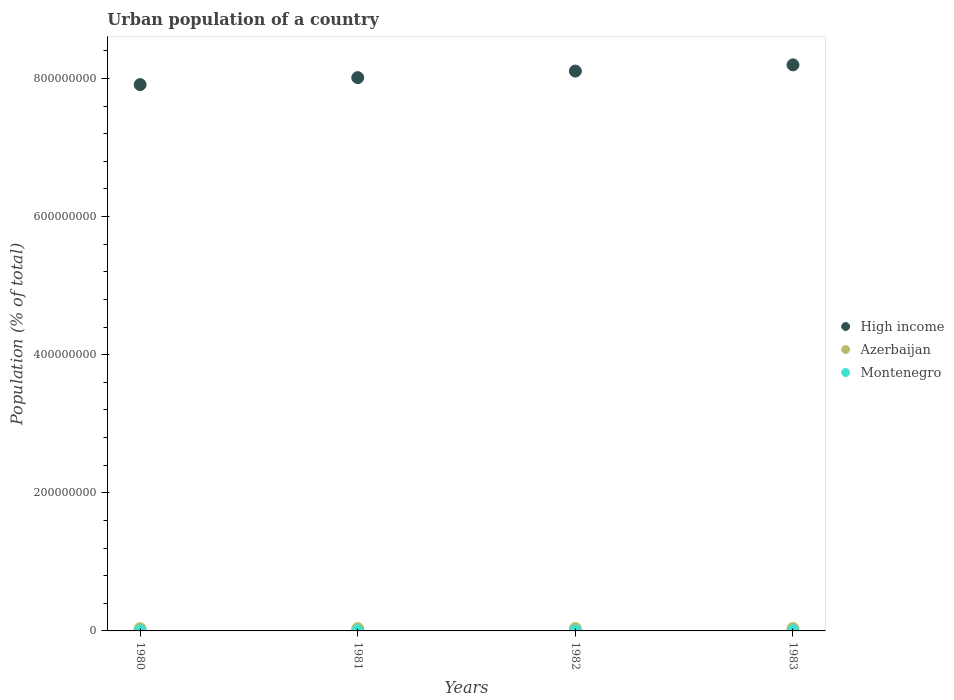Is the number of dotlines equal to the number of legend labels?
Make the answer very short. Yes. What is the urban population in Azerbaijan in 1982?
Offer a terse response. 3.37e+06. Across all years, what is the maximum urban population in High income?
Provide a short and direct response. 8.20e+08. Across all years, what is the minimum urban population in High income?
Make the answer very short. 7.91e+08. In which year was the urban population in Montenegro maximum?
Provide a short and direct response. 1983. What is the total urban population in Montenegro in the graph?
Ensure brevity in your answer.  8.89e+05. What is the difference between the urban population in High income in 1981 and that in 1983?
Give a very brief answer. -1.85e+07. What is the difference between the urban population in High income in 1983 and the urban population in Azerbaijan in 1980?
Offer a very short reply. 8.16e+08. What is the average urban population in Montenegro per year?
Your answer should be very brief. 2.22e+05. In the year 1983, what is the difference between the urban population in Montenegro and urban population in Azerbaijan?
Provide a short and direct response. -3.20e+06. In how many years, is the urban population in High income greater than 40000000 %?
Make the answer very short. 4. What is the ratio of the urban population in Montenegro in 1981 to that in 1983?
Offer a very short reply. 0.94. What is the difference between the highest and the second highest urban population in Azerbaijan?
Provide a succinct answer. 6.22e+04. What is the difference between the highest and the lowest urban population in High income?
Ensure brevity in your answer.  2.86e+07. Does the urban population in Montenegro monotonically increase over the years?
Give a very brief answer. Yes. Is the urban population in Azerbaijan strictly greater than the urban population in High income over the years?
Keep it short and to the point. No. Are the values on the major ticks of Y-axis written in scientific E-notation?
Keep it short and to the point. No. Where does the legend appear in the graph?
Offer a very short reply. Center right. How many legend labels are there?
Provide a short and direct response. 3. What is the title of the graph?
Provide a short and direct response. Urban population of a country. Does "Sub-Saharan Africa (developing only)" appear as one of the legend labels in the graph?
Keep it short and to the point. No. What is the label or title of the Y-axis?
Offer a terse response. Population (% of total). What is the Population (% of total) in High income in 1980?
Provide a short and direct response. 7.91e+08. What is the Population (% of total) in Azerbaijan in 1980?
Keep it short and to the point. 3.25e+06. What is the Population (% of total) of Montenegro in 1980?
Give a very brief answer. 2.11e+05. What is the Population (% of total) in High income in 1981?
Your answer should be very brief. 8.01e+08. What is the Population (% of total) in Azerbaijan in 1981?
Provide a short and direct response. 3.31e+06. What is the Population (% of total) of Montenegro in 1981?
Keep it short and to the point. 2.19e+05. What is the Population (% of total) of High income in 1982?
Give a very brief answer. 8.11e+08. What is the Population (% of total) of Azerbaijan in 1982?
Ensure brevity in your answer.  3.37e+06. What is the Population (% of total) in Montenegro in 1982?
Your answer should be compact. 2.26e+05. What is the Population (% of total) in High income in 1983?
Offer a very short reply. 8.20e+08. What is the Population (% of total) in Azerbaijan in 1983?
Your response must be concise. 3.44e+06. What is the Population (% of total) in Montenegro in 1983?
Your response must be concise. 2.33e+05. Across all years, what is the maximum Population (% of total) of High income?
Provide a short and direct response. 8.20e+08. Across all years, what is the maximum Population (% of total) in Azerbaijan?
Make the answer very short. 3.44e+06. Across all years, what is the maximum Population (% of total) in Montenegro?
Provide a succinct answer. 2.33e+05. Across all years, what is the minimum Population (% of total) of High income?
Provide a succinct answer. 7.91e+08. Across all years, what is the minimum Population (% of total) of Azerbaijan?
Make the answer very short. 3.25e+06. Across all years, what is the minimum Population (% of total) in Montenegro?
Your answer should be compact. 2.11e+05. What is the total Population (% of total) in High income in the graph?
Your answer should be compact. 3.22e+09. What is the total Population (% of total) in Azerbaijan in the graph?
Give a very brief answer. 1.34e+07. What is the total Population (% of total) in Montenegro in the graph?
Make the answer very short. 8.89e+05. What is the difference between the Population (% of total) of High income in 1980 and that in 1981?
Make the answer very short. -1.01e+07. What is the difference between the Population (% of total) of Azerbaijan in 1980 and that in 1981?
Offer a terse response. -5.92e+04. What is the difference between the Population (% of total) in Montenegro in 1980 and that in 1981?
Your answer should be very brief. -7514. What is the difference between the Population (% of total) in High income in 1980 and that in 1982?
Offer a terse response. -1.96e+07. What is the difference between the Population (% of total) of Azerbaijan in 1980 and that in 1982?
Give a very brief answer. -1.20e+05. What is the difference between the Population (% of total) of Montenegro in 1980 and that in 1982?
Ensure brevity in your answer.  -1.49e+04. What is the difference between the Population (% of total) in High income in 1980 and that in 1983?
Make the answer very short. -2.86e+07. What is the difference between the Population (% of total) of Azerbaijan in 1980 and that in 1983?
Your answer should be compact. -1.82e+05. What is the difference between the Population (% of total) in Montenegro in 1980 and that in 1983?
Offer a very short reply. -2.24e+04. What is the difference between the Population (% of total) of High income in 1981 and that in 1982?
Keep it short and to the point. -9.48e+06. What is the difference between the Population (% of total) in Azerbaijan in 1981 and that in 1982?
Provide a short and direct response. -6.08e+04. What is the difference between the Population (% of total) of Montenegro in 1981 and that in 1982?
Keep it short and to the point. -7429. What is the difference between the Population (% of total) of High income in 1981 and that in 1983?
Ensure brevity in your answer.  -1.85e+07. What is the difference between the Population (% of total) of Azerbaijan in 1981 and that in 1983?
Ensure brevity in your answer.  -1.23e+05. What is the difference between the Population (% of total) of Montenegro in 1981 and that in 1983?
Keep it short and to the point. -1.49e+04. What is the difference between the Population (% of total) of High income in 1982 and that in 1983?
Keep it short and to the point. -9.01e+06. What is the difference between the Population (% of total) of Azerbaijan in 1982 and that in 1983?
Give a very brief answer. -6.22e+04. What is the difference between the Population (% of total) of Montenegro in 1982 and that in 1983?
Offer a terse response. -7455. What is the difference between the Population (% of total) in High income in 1980 and the Population (% of total) in Azerbaijan in 1981?
Offer a very short reply. 7.88e+08. What is the difference between the Population (% of total) in High income in 1980 and the Population (% of total) in Montenegro in 1981?
Offer a very short reply. 7.91e+08. What is the difference between the Population (% of total) in Azerbaijan in 1980 and the Population (% of total) in Montenegro in 1981?
Your answer should be compact. 3.03e+06. What is the difference between the Population (% of total) in High income in 1980 and the Population (% of total) in Azerbaijan in 1982?
Offer a very short reply. 7.88e+08. What is the difference between the Population (% of total) of High income in 1980 and the Population (% of total) of Montenegro in 1982?
Your response must be concise. 7.91e+08. What is the difference between the Population (% of total) of Azerbaijan in 1980 and the Population (% of total) of Montenegro in 1982?
Keep it short and to the point. 3.03e+06. What is the difference between the Population (% of total) in High income in 1980 and the Population (% of total) in Azerbaijan in 1983?
Ensure brevity in your answer.  7.88e+08. What is the difference between the Population (% of total) in High income in 1980 and the Population (% of total) in Montenegro in 1983?
Your response must be concise. 7.91e+08. What is the difference between the Population (% of total) of Azerbaijan in 1980 and the Population (% of total) of Montenegro in 1983?
Your response must be concise. 3.02e+06. What is the difference between the Population (% of total) of High income in 1981 and the Population (% of total) of Azerbaijan in 1982?
Provide a succinct answer. 7.98e+08. What is the difference between the Population (% of total) in High income in 1981 and the Population (% of total) in Montenegro in 1982?
Offer a very short reply. 8.01e+08. What is the difference between the Population (% of total) of Azerbaijan in 1981 and the Population (% of total) of Montenegro in 1982?
Your response must be concise. 3.09e+06. What is the difference between the Population (% of total) of High income in 1981 and the Population (% of total) of Azerbaijan in 1983?
Your response must be concise. 7.98e+08. What is the difference between the Population (% of total) of High income in 1981 and the Population (% of total) of Montenegro in 1983?
Offer a very short reply. 8.01e+08. What is the difference between the Population (% of total) in Azerbaijan in 1981 and the Population (% of total) in Montenegro in 1983?
Your response must be concise. 3.08e+06. What is the difference between the Population (% of total) in High income in 1982 and the Population (% of total) in Azerbaijan in 1983?
Offer a terse response. 8.07e+08. What is the difference between the Population (% of total) of High income in 1982 and the Population (% of total) of Montenegro in 1983?
Your answer should be compact. 8.10e+08. What is the difference between the Population (% of total) in Azerbaijan in 1982 and the Population (% of total) in Montenegro in 1983?
Your answer should be compact. 3.14e+06. What is the average Population (% of total) in High income per year?
Your answer should be compact. 8.06e+08. What is the average Population (% of total) of Azerbaijan per year?
Provide a short and direct response. 3.34e+06. What is the average Population (% of total) of Montenegro per year?
Give a very brief answer. 2.22e+05. In the year 1980, what is the difference between the Population (% of total) in High income and Population (% of total) in Azerbaijan?
Offer a terse response. 7.88e+08. In the year 1980, what is the difference between the Population (% of total) of High income and Population (% of total) of Montenegro?
Offer a terse response. 7.91e+08. In the year 1980, what is the difference between the Population (% of total) in Azerbaijan and Population (% of total) in Montenegro?
Keep it short and to the point. 3.04e+06. In the year 1981, what is the difference between the Population (% of total) in High income and Population (% of total) in Azerbaijan?
Offer a very short reply. 7.98e+08. In the year 1981, what is the difference between the Population (% of total) of High income and Population (% of total) of Montenegro?
Your answer should be compact. 8.01e+08. In the year 1981, what is the difference between the Population (% of total) in Azerbaijan and Population (% of total) in Montenegro?
Ensure brevity in your answer.  3.09e+06. In the year 1982, what is the difference between the Population (% of total) in High income and Population (% of total) in Azerbaijan?
Give a very brief answer. 8.07e+08. In the year 1982, what is the difference between the Population (% of total) of High income and Population (% of total) of Montenegro?
Keep it short and to the point. 8.10e+08. In the year 1982, what is the difference between the Population (% of total) in Azerbaijan and Population (% of total) in Montenegro?
Ensure brevity in your answer.  3.15e+06. In the year 1983, what is the difference between the Population (% of total) in High income and Population (% of total) in Azerbaijan?
Ensure brevity in your answer.  8.16e+08. In the year 1983, what is the difference between the Population (% of total) in High income and Population (% of total) in Montenegro?
Make the answer very short. 8.19e+08. In the year 1983, what is the difference between the Population (% of total) of Azerbaijan and Population (% of total) of Montenegro?
Your response must be concise. 3.20e+06. What is the ratio of the Population (% of total) in High income in 1980 to that in 1981?
Provide a short and direct response. 0.99. What is the ratio of the Population (% of total) of Azerbaijan in 1980 to that in 1981?
Give a very brief answer. 0.98. What is the ratio of the Population (% of total) in Montenegro in 1980 to that in 1981?
Your response must be concise. 0.97. What is the ratio of the Population (% of total) in High income in 1980 to that in 1982?
Offer a terse response. 0.98. What is the ratio of the Population (% of total) in Azerbaijan in 1980 to that in 1982?
Keep it short and to the point. 0.96. What is the ratio of the Population (% of total) in Montenegro in 1980 to that in 1982?
Offer a terse response. 0.93. What is the ratio of the Population (% of total) of High income in 1980 to that in 1983?
Provide a short and direct response. 0.97. What is the ratio of the Population (% of total) of Azerbaijan in 1980 to that in 1983?
Provide a succinct answer. 0.95. What is the ratio of the Population (% of total) of Montenegro in 1980 to that in 1983?
Ensure brevity in your answer.  0.9. What is the ratio of the Population (% of total) in High income in 1981 to that in 1982?
Make the answer very short. 0.99. What is the ratio of the Population (% of total) in Montenegro in 1981 to that in 1982?
Keep it short and to the point. 0.97. What is the ratio of the Population (% of total) of High income in 1981 to that in 1983?
Your answer should be compact. 0.98. What is the ratio of the Population (% of total) of Azerbaijan in 1981 to that in 1983?
Provide a succinct answer. 0.96. What is the ratio of the Population (% of total) in Montenegro in 1981 to that in 1983?
Provide a short and direct response. 0.94. What is the ratio of the Population (% of total) of Azerbaijan in 1982 to that in 1983?
Keep it short and to the point. 0.98. What is the ratio of the Population (% of total) in Montenegro in 1982 to that in 1983?
Your answer should be very brief. 0.97. What is the difference between the highest and the second highest Population (% of total) of High income?
Give a very brief answer. 9.01e+06. What is the difference between the highest and the second highest Population (% of total) in Azerbaijan?
Your answer should be very brief. 6.22e+04. What is the difference between the highest and the second highest Population (% of total) in Montenegro?
Provide a short and direct response. 7455. What is the difference between the highest and the lowest Population (% of total) in High income?
Your answer should be very brief. 2.86e+07. What is the difference between the highest and the lowest Population (% of total) of Azerbaijan?
Your answer should be very brief. 1.82e+05. What is the difference between the highest and the lowest Population (% of total) in Montenegro?
Your answer should be compact. 2.24e+04. 